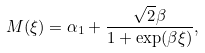Convert formula to latex. <formula><loc_0><loc_0><loc_500><loc_500>M ( \xi ) = \alpha _ { 1 } + \frac { \sqrt { 2 } \beta } { 1 + \exp ( \beta \xi ) } ,</formula> 